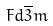Convert formula to latex. <formula><loc_0><loc_0><loc_500><loc_500>F d \overline { 3 } m</formula> 